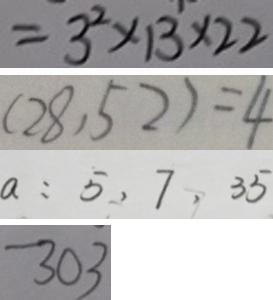<formula> <loc_0><loc_0><loc_500><loc_500>= 3 ^ { 2 } \times 1 3 \times 2 2 
 ( 2 8 , 5 2 ) = 4 
 a : 5 , 7 , 3 5 
 3 0 3</formula> 